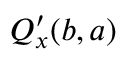<formula> <loc_0><loc_0><loc_500><loc_500>Q _ { x } ^ { \prime } ( b , a )</formula> 